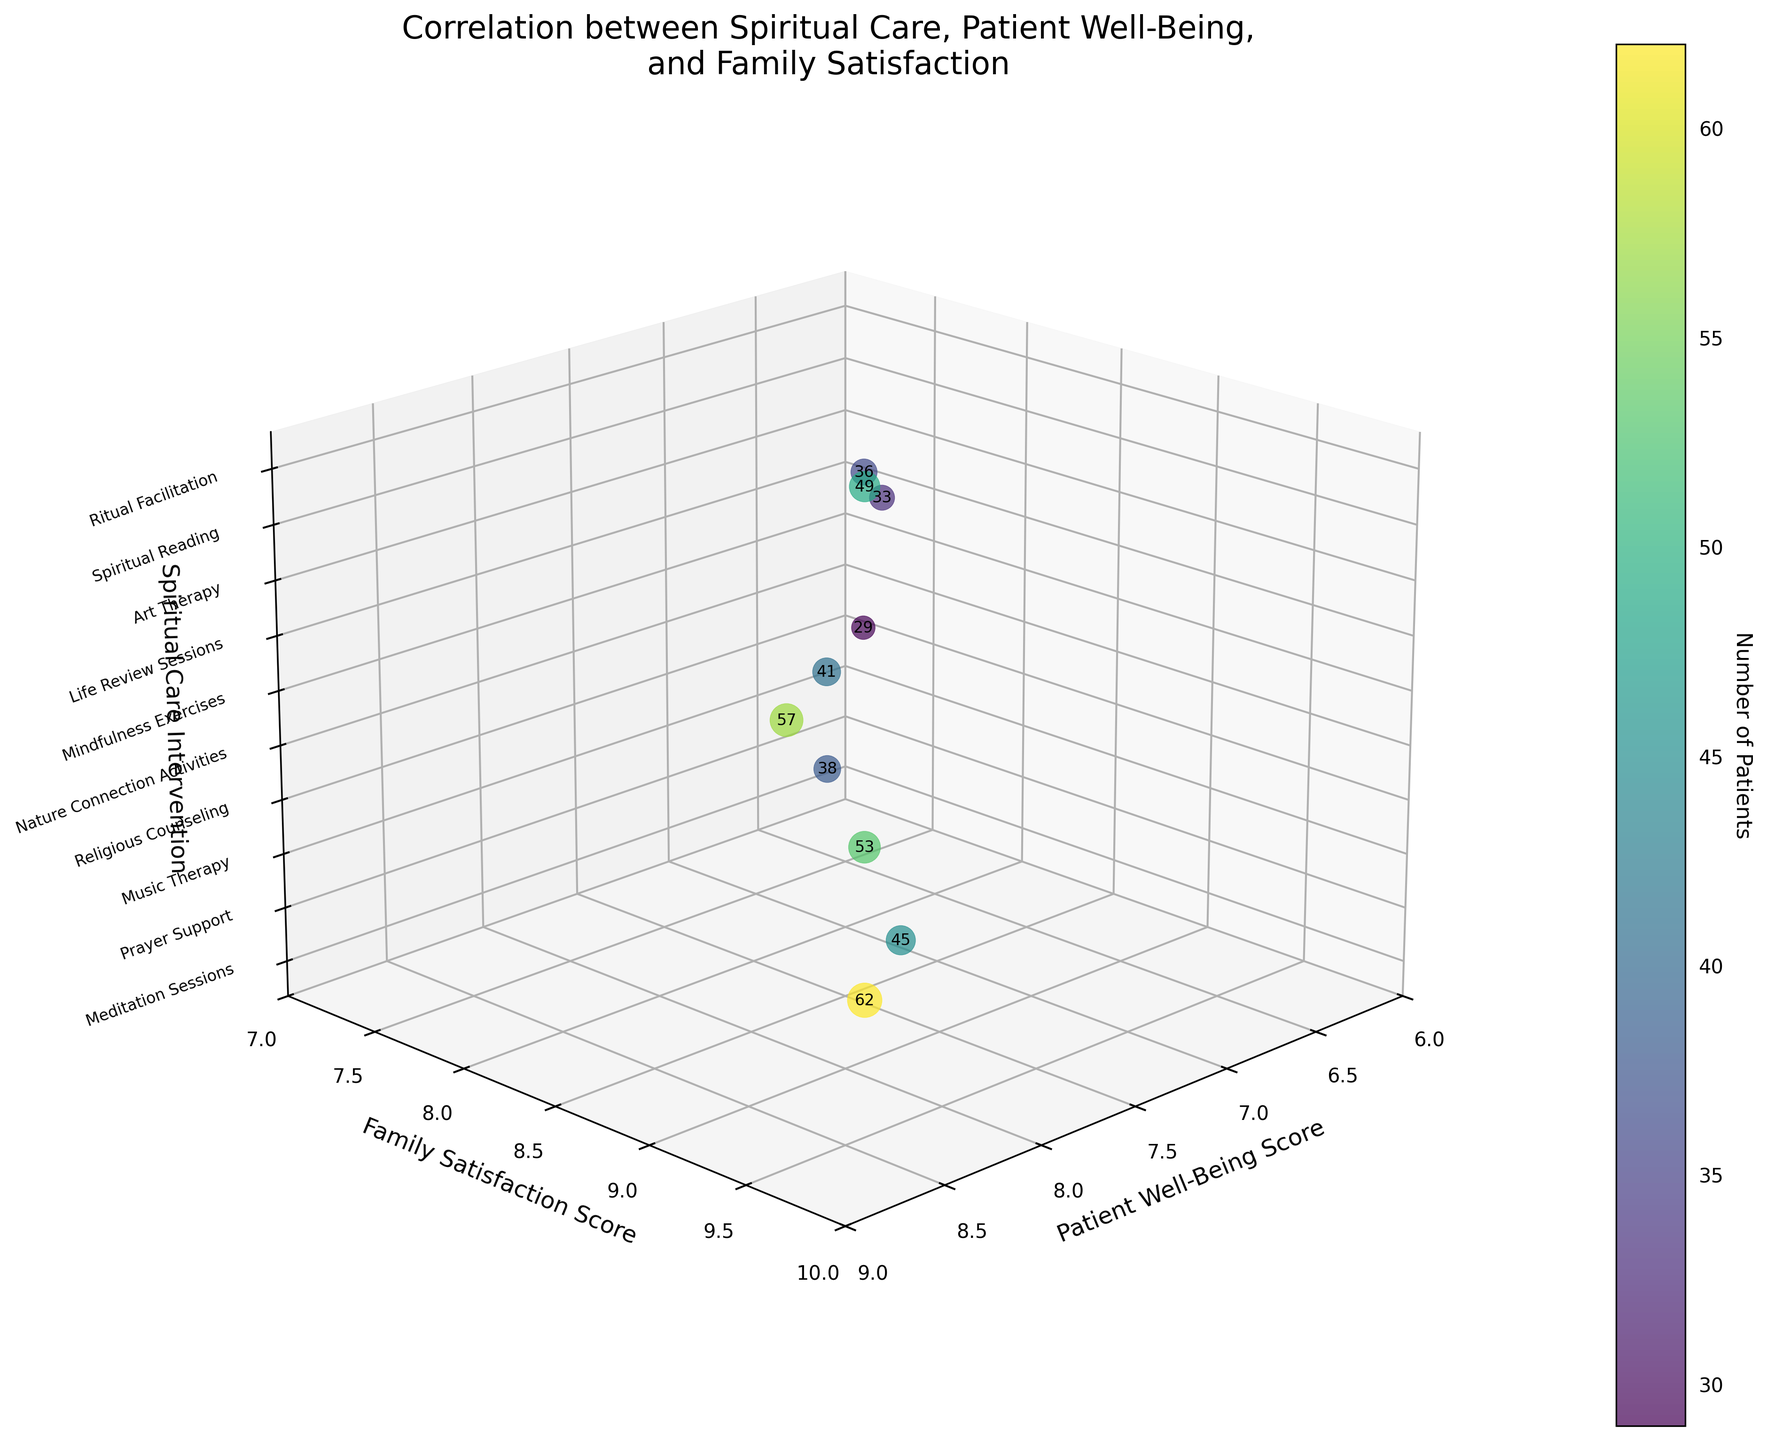What is the title of the figure? The title is located at the top of the figure and provides an overview description.
Answer: Correlation between Spiritual Care, Patient Well-Being, and Family Satisfaction What does the color of the bubbles represent? The color indicates the number of patients involved in each spiritual care intervention. This can be identified through the color bar labeled "Number of Patients" on the side of the chart.
Answer: Number of Patients Which spiritual care intervention has the highest family satisfaction score? Locate the position on the Y-axis with the highest value and refer to the Z-axis label at that position.
Answer: Prayer Support What is the range of patient well-being scores represented in the figure? Check the values on the X-axis, which range from the minimum to maximum patient well-being scores.
Answer: 6 to 9 How many patients were involved in Meditation Sessions? Look at the label next to the bubble representing Meditation Sessions, which indicates the number of patients.
Answer: 45 Which spiritual care intervention is associated with the lowest patient well-being score? Identify the lowest point on the X-axis and refer to the corresponding label on the Z-axis.
Answer: Nature Connection Activities What is the average family satisfaction score for Meditation Sessions and Music Therapy? Add the family satisfaction scores for the two interventions (8.5 and 7.8), then divide by 2.
Answer: (8.5 + 7.8) / 2 = 16.3 / 2 = 8.15 Which interventions have both patient well-being and family satisfaction scores above 8.0? Identify bubbles whose X-axis and Y-axis values are both greater than 8.0 and check the corresponding labels.
Answer: Prayer Support, Life Review Sessions Compare the number of patients between Prayer Support and Art Therapy. Which has more? Locate the bubbles for both interventions and check the numbers next to each.
Answer: Prayer Support What is the size difference between the bubbles for Ritual Facilitation and Nature Connection Activities? Subtract the number of patients for Nature Connection Activities from that for Ritual Facilitation, then multiply by 5 (according to the scaling factor).
Answer: (49 - 29) * 5 = 20 * 5 = 100 